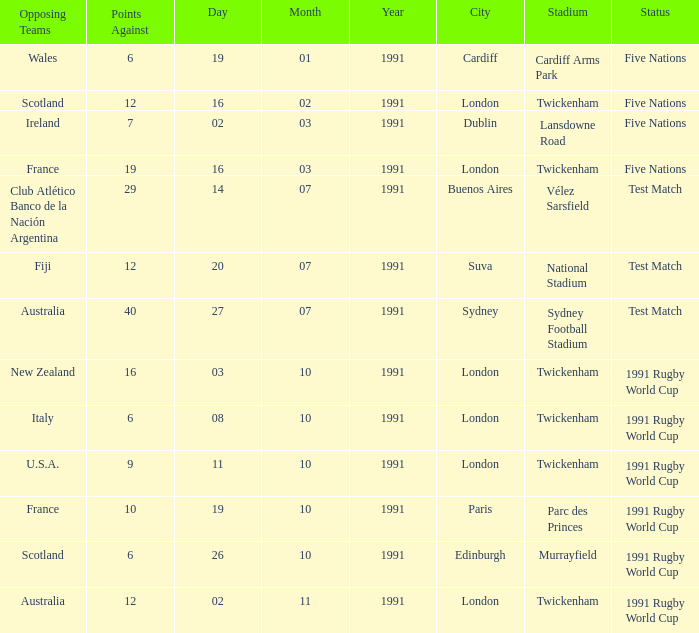When is the match scheduled, with "australia" as the opposing team and "twickenham, london" as the location? 02/11/1991. Can you parse all the data within this table? {'header': ['Opposing Teams', 'Points Against', 'Day', 'Month', 'Year', 'City', 'Stadium', 'Status'], 'rows': [['Wales', '6', '19', '01', '1991', 'Cardiff', 'Cardiff Arms Park', 'Five Nations'], ['Scotland', '12', '16', '02', '1991', 'London', 'Twickenham', 'Five Nations'], ['Ireland', '7', '02', '03', '1991', 'Dublin', 'Lansdowne Road', 'Five Nations'], ['France', '19', '16', '03', '1991', 'London', 'Twickenham', 'Five Nations'], ['Club Atlético Banco de la Nación Argentina', '29', '14', '07', '1991', 'Buenos Aires', 'Vélez Sarsfield', 'Test Match'], ['Fiji', '12', '20', '07', '1991', 'Suva', 'National Stadium', 'Test Match'], ['Australia', '40', '27', '07', '1991', 'Sydney', 'Sydney Football Stadium', 'Test Match'], ['New Zealand', '16', '03', '10', '1991', 'London', 'Twickenham', '1991 Rugby World Cup'], ['Italy', '6', '08', '10', '1991', 'London', 'Twickenham', '1991 Rugby World Cup'], ['U.S.A.', '9', '11', '10', '1991', 'London', 'Twickenham', '1991 Rugby World Cup'], ['France', '10', '19', '10', '1991', 'Paris', 'Parc des Princes', '1991 Rugby World Cup'], ['Scotland', '6', '26', '10', '1991', 'Edinburgh', 'Murrayfield', '1991 Rugby World Cup'], ['Australia', '12', '02', '11', '1991', 'London', 'Twickenham', '1991 Rugby World Cup']]} 